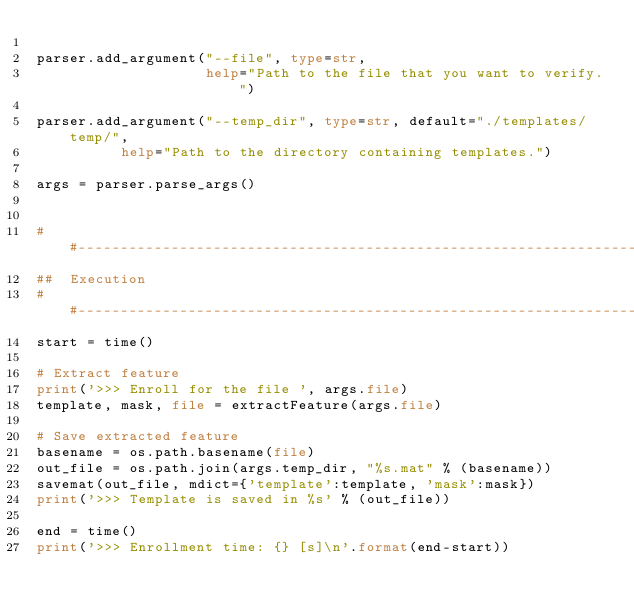<code> <loc_0><loc_0><loc_500><loc_500><_Python_>
parser.add_argument("--file", type=str,
                    help="Path to the file that you want to verify.")

parser.add_argument("--temp_dir", type=str, default="./templates/temp/",
					help="Path to the directory containing templates.")

args = parser.parse_args()


##-----------------------------------------------------------------------------
##  Execution
##-----------------------------------------------------------------------------
start = time()

# Extract feature
print('>>> Enroll for the file ', args.file)
template, mask, file = extractFeature(args.file)

# Save extracted feature
basename = os.path.basename(file)
out_file = os.path.join(args.temp_dir, "%s.mat" % (basename))
savemat(out_file, mdict={'template':template, 'mask':mask})
print('>>> Template is saved in %s' % (out_file))

end = time()
print('>>> Enrollment time: {} [s]\n'.format(end-start))</code> 